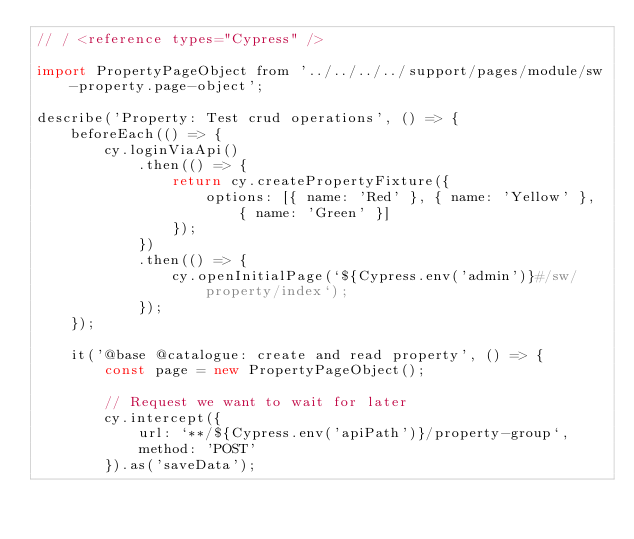Convert code to text. <code><loc_0><loc_0><loc_500><loc_500><_JavaScript_>// / <reference types="Cypress" />

import PropertyPageObject from '../../../../support/pages/module/sw-property.page-object';

describe('Property: Test crud operations', () => {
    beforeEach(() => {
        cy.loginViaApi()
            .then(() => {
                return cy.createPropertyFixture({
                    options: [{ name: 'Red' }, { name: 'Yellow' }, { name: 'Green' }]
                });
            })
            .then(() => {
                cy.openInitialPage(`${Cypress.env('admin')}#/sw/property/index`);
            });
    });

    it('@base @catalogue: create and read property', () => {
        const page = new PropertyPageObject();

        // Request we want to wait for later
        cy.intercept({
            url: `**/${Cypress.env('apiPath')}/property-group`,
            method: 'POST'
        }).as('saveData');
</code> 